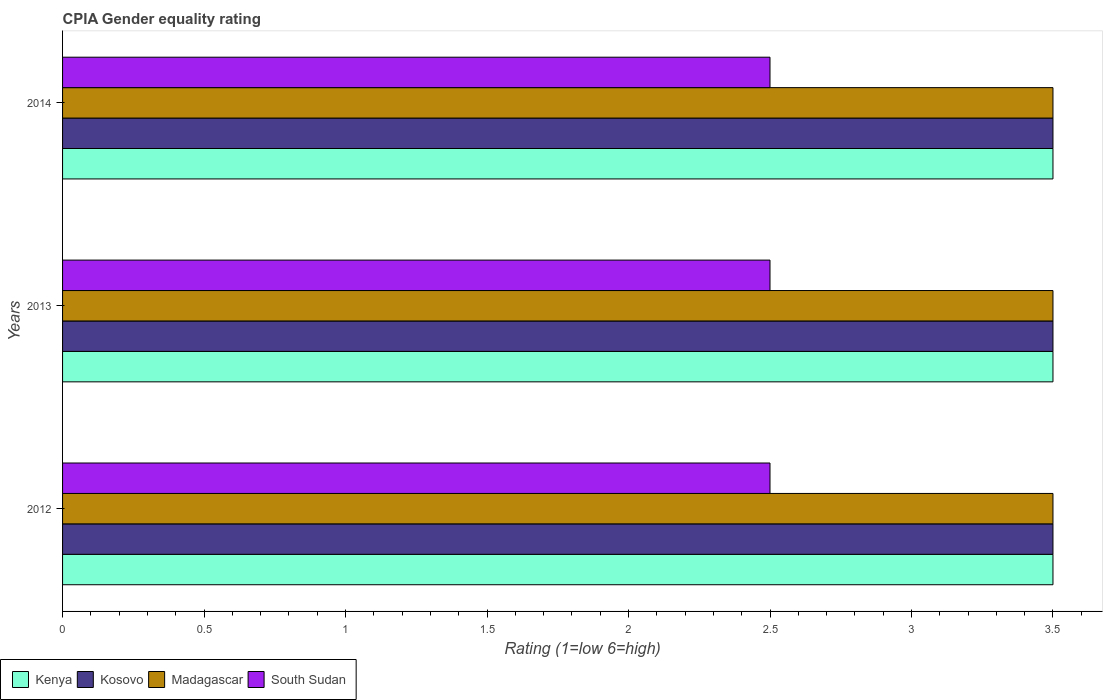Are the number of bars on each tick of the Y-axis equal?
Give a very brief answer. Yes. What is the label of the 3rd group of bars from the top?
Offer a terse response. 2012. In how many cases, is the number of bars for a given year not equal to the number of legend labels?
Provide a short and direct response. 0. In which year was the CPIA rating in Kenya maximum?
Your answer should be compact. 2012. In which year was the CPIA rating in Kosovo minimum?
Your answer should be compact. 2012. What is the total CPIA rating in Kenya in the graph?
Ensure brevity in your answer.  10.5. What is the difference between the CPIA rating in Kosovo in 2012 and that in 2013?
Your response must be concise. 0. What is the difference between the CPIA rating in Madagascar in 2013 and the CPIA rating in Kenya in 2012?
Your answer should be compact. 0. What is the average CPIA rating in Kenya per year?
Offer a terse response. 3.5. Is the CPIA rating in Kenya in 2012 less than that in 2013?
Provide a short and direct response. No. Is it the case that in every year, the sum of the CPIA rating in Madagascar and CPIA rating in South Sudan is greater than the sum of CPIA rating in Kosovo and CPIA rating in Kenya?
Offer a terse response. No. What does the 1st bar from the top in 2014 represents?
Your answer should be compact. South Sudan. What does the 1st bar from the bottom in 2012 represents?
Offer a terse response. Kenya. Is it the case that in every year, the sum of the CPIA rating in Madagascar and CPIA rating in Kenya is greater than the CPIA rating in South Sudan?
Offer a very short reply. Yes. Are all the bars in the graph horizontal?
Keep it short and to the point. Yes. How many years are there in the graph?
Offer a terse response. 3. Are the values on the major ticks of X-axis written in scientific E-notation?
Provide a short and direct response. No. How many legend labels are there?
Give a very brief answer. 4. How are the legend labels stacked?
Keep it short and to the point. Horizontal. What is the title of the graph?
Your response must be concise. CPIA Gender equality rating. Does "Trinidad and Tobago" appear as one of the legend labels in the graph?
Ensure brevity in your answer.  No. What is the label or title of the X-axis?
Give a very brief answer. Rating (1=low 6=high). What is the Rating (1=low 6=high) of Kenya in 2012?
Give a very brief answer. 3.5. What is the Rating (1=low 6=high) in South Sudan in 2012?
Offer a terse response. 2.5. What is the Rating (1=low 6=high) of South Sudan in 2013?
Your answer should be very brief. 2.5. What is the Rating (1=low 6=high) in Kenya in 2014?
Provide a short and direct response. 3.5. What is the Rating (1=low 6=high) of Kosovo in 2014?
Give a very brief answer. 3.5. What is the Rating (1=low 6=high) of South Sudan in 2014?
Offer a very short reply. 2.5. Across all years, what is the maximum Rating (1=low 6=high) of Kenya?
Keep it short and to the point. 3.5. Across all years, what is the maximum Rating (1=low 6=high) in Madagascar?
Your answer should be compact. 3.5. Across all years, what is the maximum Rating (1=low 6=high) of South Sudan?
Give a very brief answer. 2.5. Across all years, what is the minimum Rating (1=low 6=high) of Madagascar?
Provide a short and direct response. 3.5. What is the total Rating (1=low 6=high) in Madagascar in the graph?
Provide a short and direct response. 10.5. What is the total Rating (1=low 6=high) in South Sudan in the graph?
Ensure brevity in your answer.  7.5. What is the difference between the Rating (1=low 6=high) of Madagascar in 2012 and that in 2013?
Provide a short and direct response. 0. What is the difference between the Rating (1=low 6=high) in Madagascar in 2012 and that in 2014?
Provide a succinct answer. 0. What is the difference between the Rating (1=low 6=high) in Kosovo in 2013 and that in 2014?
Your response must be concise. 0. What is the difference between the Rating (1=low 6=high) of Kenya in 2012 and the Rating (1=low 6=high) of Madagascar in 2013?
Provide a succinct answer. 0. What is the difference between the Rating (1=low 6=high) in Kenya in 2012 and the Rating (1=low 6=high) in South Sudan in 2013?
Make the answer very short. 1. What is the difference between the Rating (1=low 6=high) in Kosovo in 2012 and the Rating (1=low 6=high) in Madagascar in 2013?
Your answer should be compact. 0. What is the difference between the Rating (1=low 6=high) of Kosovo in 2012 and the Rating (1=low 6=high) of South Sudan in 2013?
Provide a succinct answer. 1. What is the difference between the Rating (1=low 6=high) of Kosovo in 2012 and the Rating (1=low 6=high) of Madagascar in 2014?
Offer a terse response. 0. What is the difference between the Rating (1=low 6=high) of Madagascar in 2012 and the Rating (1=low 6=high) of South Sudan in 2014?
Provide a short and direct response. 1. What is the difference between the Rating (1=low 6=high) of Kenya in 2013 and the Rating (1=low 6=high) of South Sudan in 2014?
Provide a succinct answer. 1. What is the difference between the Rating (1=low 6=high) of Kosovo in 2013 and the Rating (1=low 6=high) of Madagascar in 2014?
Your answer should be very brief. 0. What is the average Rating (1=low 6=high) of Kosovo per year?
Offer a very short reply. 3.5. What is the average Rating (1=low 6=high) of Madagascar per year?
Ensure brevity in your answer.  3.5. In the year 2012, what is the difference between the Rating (1=low 6=high) in Kenya and Rating (1=low 6=high) in Madagascar?
Your answer should be very brief. 0. In the year 2012, what is the difference between the Rating (1=low 6=high) in Kosovo and Rating (1=low 6=high) in Madagascar?
Offer a terse response. 0. In the year 2012, what is the difference between the Rating (1=low 6=high) in Madagascar and Rating (1=low 6=high) in South Sudan?
Provide a short and direct response. 1. In the year 2013, what is the difference between the Rating (1=low 6=high) of Kenya and Rating (1=low 6=high) of Kosovo?
Provide a succinct answer. 0. In the year 2013, what is the difference between the Rating (1=low 6=high) of Kosovo and Rating (1=low 6=high) of South Sudan?
Ensure brevity in your answer.  1. In the year 2013, what is the difference between the Rating (1=low 6=high) of Madagascar and Rating (1=low 6=high) of South Sudan?
Your answer should be compact. 1. In the year 2014, what is the difference between the Rating (1=low 6=high) of Kenya and Rating (1=low 6=high) of Madagascar?
Offer a very short reply. 0. In the year 2014, what is the difference between the Rating (1=low 6=high) in Kosovo and Rating (1=low 6=high) in Madagascar?
Offer a very short reply. 0. In the year 2014, what is the difference between the Rating (1=low 6=high) of Kosovo and Rating (1=low 6=high) of South Sudan?
Provide a succinct answer. 1. What is the ratio of the Rating (1=low 6=high) of South Sudan in 2012 to that in 2013?
Your answer should be compact. 1. What is the ratio of the Rating (1=low 6=high) in Kenya in 2013 to that in 2014?
Give a very brief answer. 1. What is the difference between the highest and the second highest Rating (1=low 6=high) in Madagascar?
Ensure brevity in your answer.  0. What is the difference between the highest and the second highest Rating (1=low 6=high) in South Sudan?
Provide a succinct answer. 0. What is the difference between the highest and the lowest Rating (1=low 6=high) of Kosovo?
Offer a very short reply. 0. What is the difference between the highest and the lowest Rating (1=low 6=high) in Madagascar?
Your response must be concise. 0. 